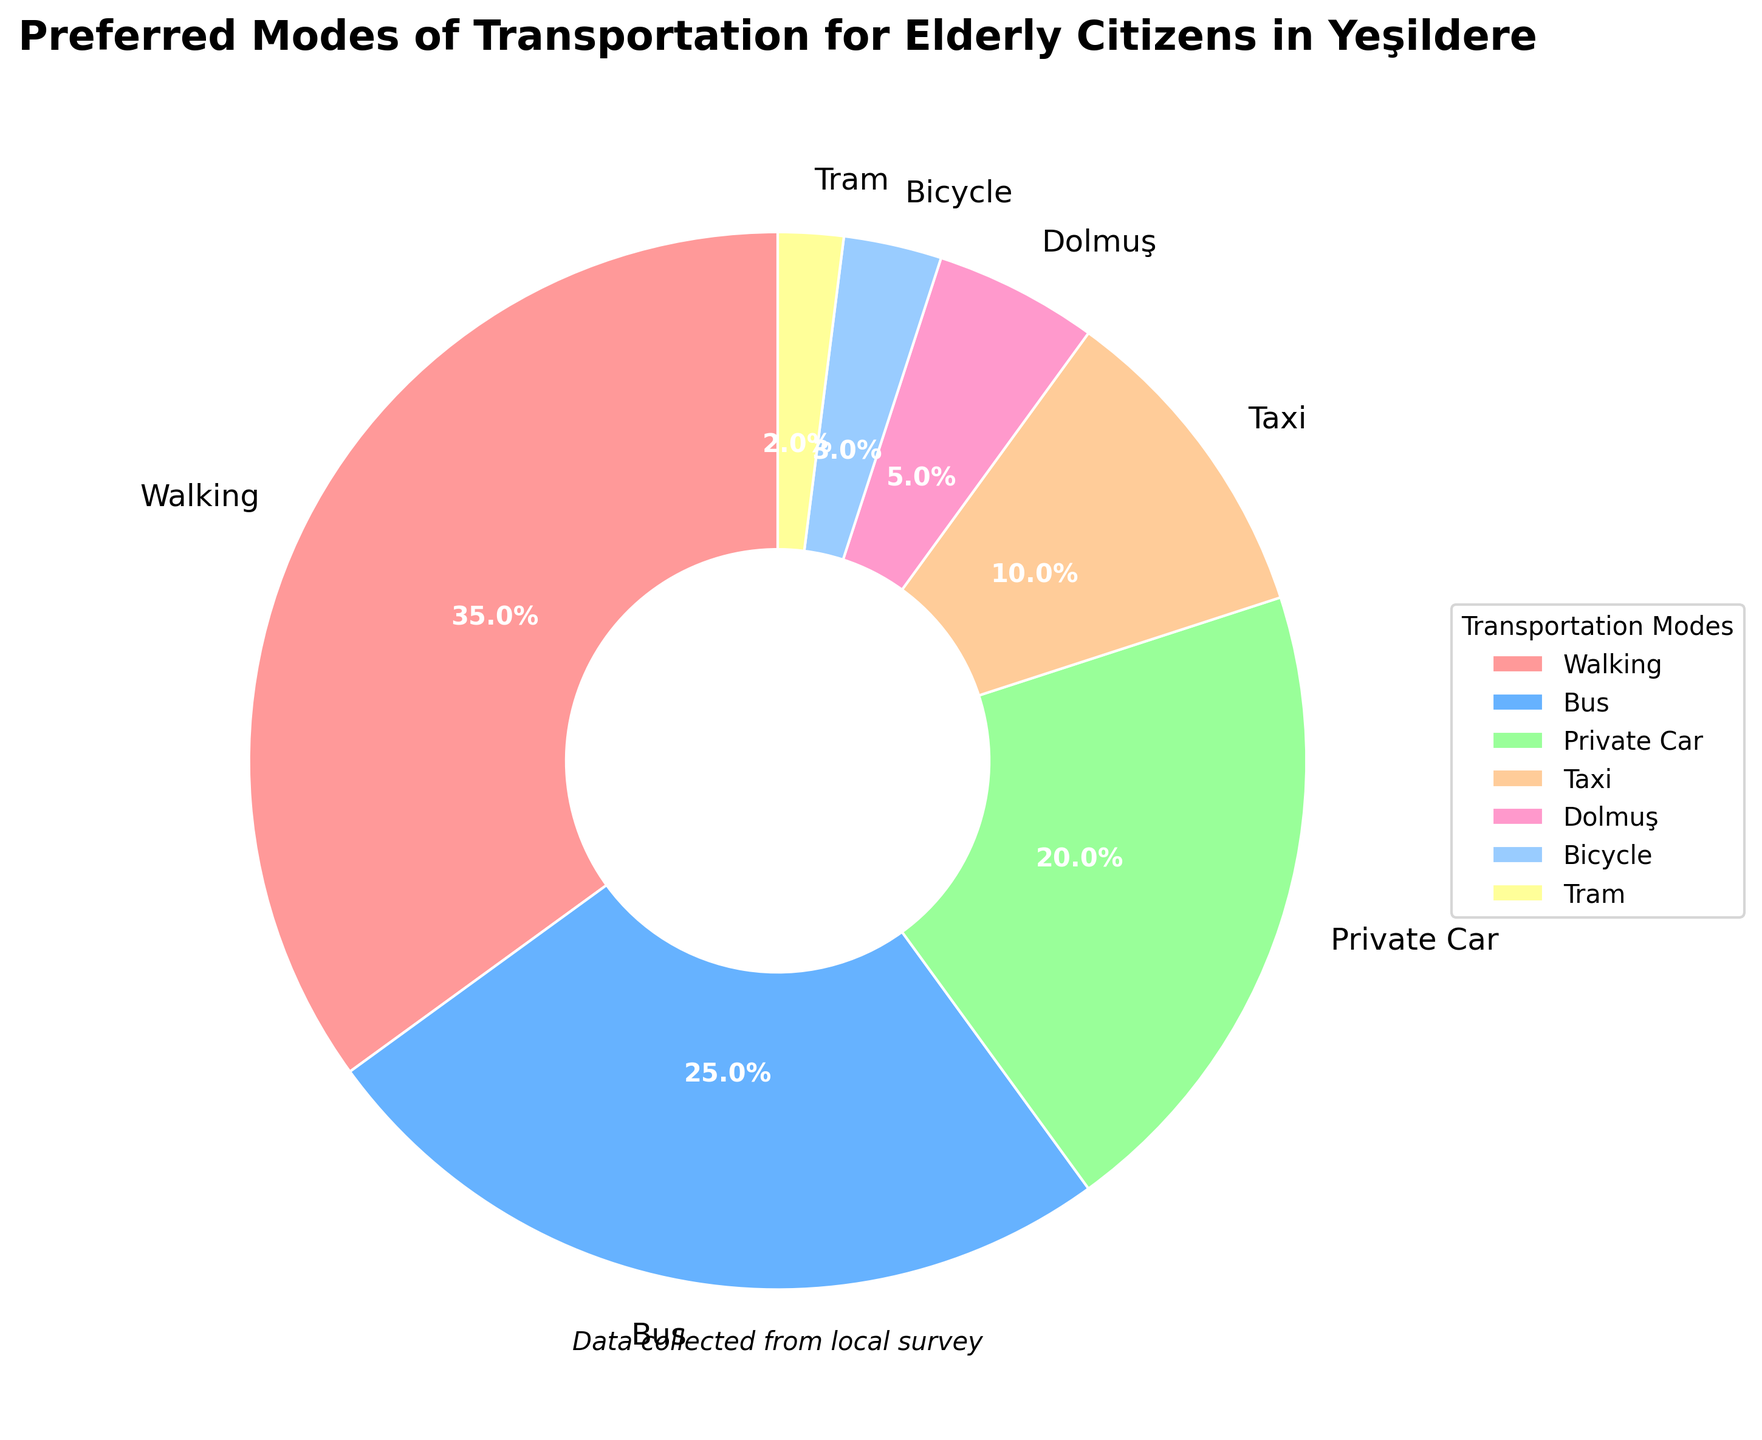What's the most preferred mode of transportation? The mode with the highest percentage on the pie chart is the most preferred. Based on the data provided, Walking has the highest percentage at 35%, making it the most preferred mode of transportation.
Answer: Walking Which mode of transportation is less preferred than Bus but more preferred than Taxi? To determine which mode falls between Bus and Taxi, find the percentages for Bus (25%) and Taxi (10%). Private Car has a percentage of 20%, which is between those values.
Answer: Private Car What is the total percentage of people preferring Bicycle and Tram combined? Add the percentages for Bicycle (3%) and Tram (2%). So, 3% + 2% = 5%.
Answer: 5% What transportation mode has a higher percentage, Bus or Private Car? Compare the percentages of Bus (25%) and Private Car (20%). Since 25% is greater than 20%, Bus has a higher percentage.
Answer: Bus How much more preferred is Walking compared to Dolmuş? Subtract the percentage for Dolmuş (5%) from the percentage for Walking (35%). So, 35% - 5% = 30%.
Answer: 30% Are there any modes of transportation with a percentage lower than 5%? Looking at the percentages, both Bicycle (3%) and Tram (2%) are lower than 5%.
Answer: Yes What is the combined percentage of the top two most preferred transportation modes? The top two modes are Walking (35%) and Bus (25%). Add these percentages together: 35% + 25% = 60%.
Answer: 60% Which mode of transportation is represented by the blue color in the pie chart? According to the description, the third color listed is blue, and looking at the data, the third mode by percentage is Private Car. Therefore, Private Car is represented by the blue color.
Answer: Private Car 